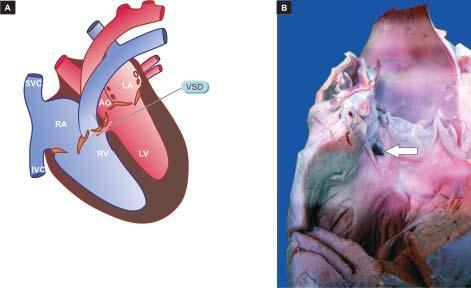what show a communication in the inter-ventricular septum superiorly white arrow?
Answer the question using a single word or phrase. Opened chambers of heart 